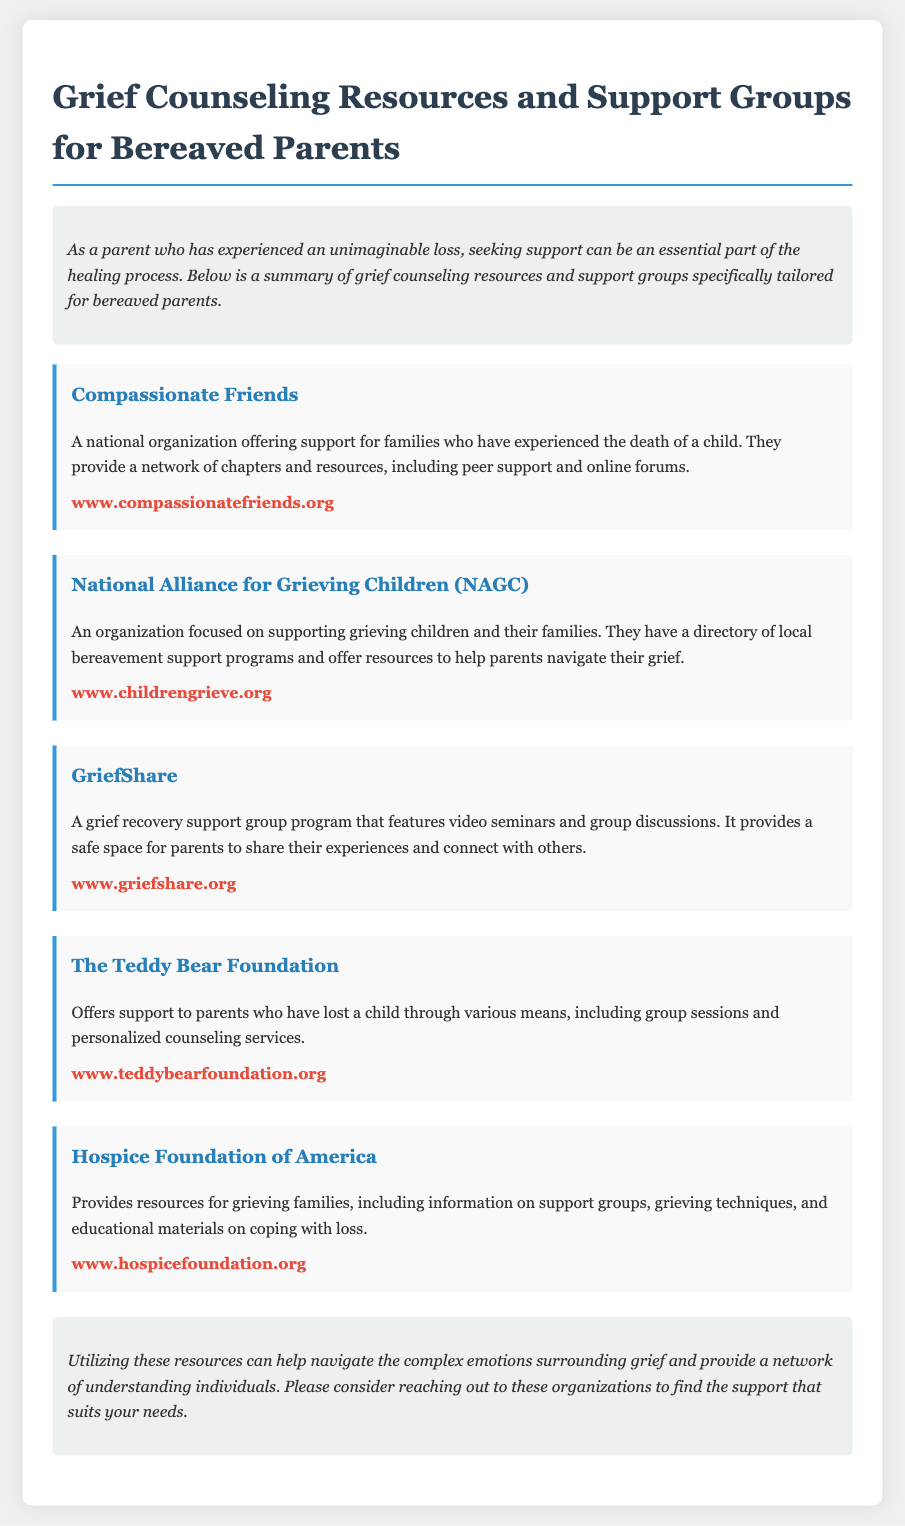What is the title of the document? The title is the main heading that summarizes the content of the document.
Answer: Grief Counseling Resources and Support Groups for Bereaved Parents How many organizations are listed in the resources section? The resources section identifies and describes several organizations that provide support.
Answer: Five What is the main purpose of The Teddy Bear Foundation? The description outlines the primary focus and services provided by this organization for bereaved parents.
Answer: Support to parents who have lost a child What type of program does GriefShare provide? The text details the nature of engagement offered through this organization's support framework.
Answer: Grief recovery support group Which organization has a focus on grieving children? The description indicates the target audience that this organization aims to support.
Answer: National Alliance for Grieving Children What can be found on the Hospice Foundation of America’s website? The text emphasizes the resources and materials available to families dealing with grief.
Answer: Resources for grieving families What kind of support does Compassionate Friends offer? The description mentions the types of assistance provided by the organization for parents who have lost a child.
Answer: Peer support and online forums Where can information about GriefShare be found? The document provides a URL for accessing the organization's website for more information.
Answer: www.griefshare.org What type of emotional needs do these resources address? The document conveys the overall purpose of these resources in relation to the emotional state of bereaved parents.
Answer: Complex emotions surrounding grief 